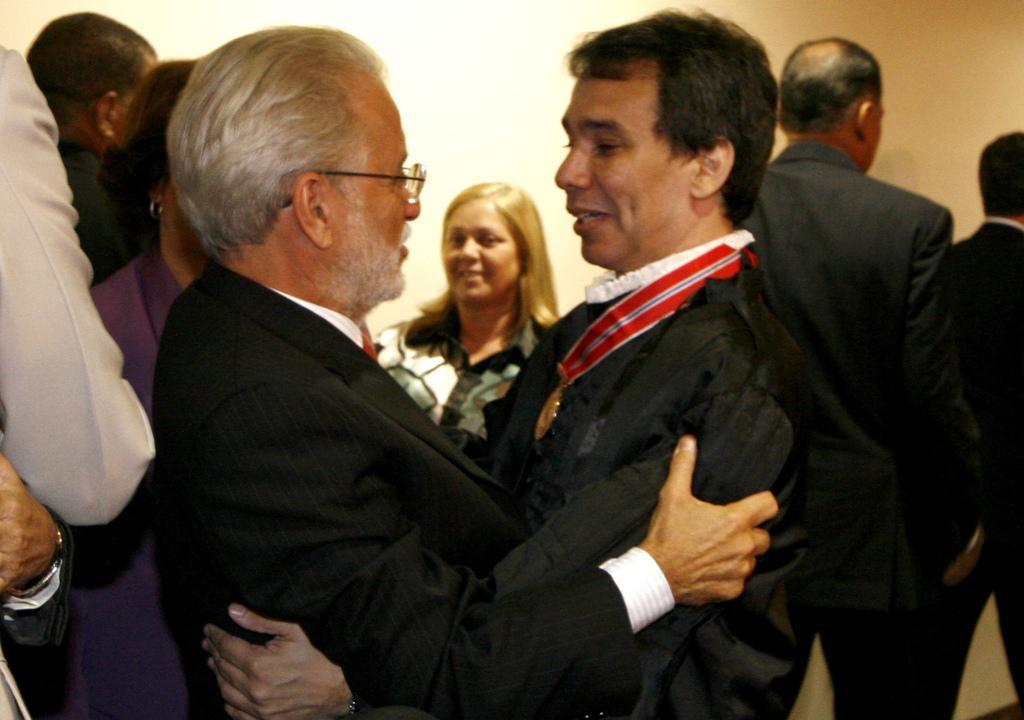How would you summarize this image in a sentence or two? In this image, we can see a group of people. Here we can see few people are smiling. In the middle of the image, we can see two people are hugging each other. Background there is a wall. 